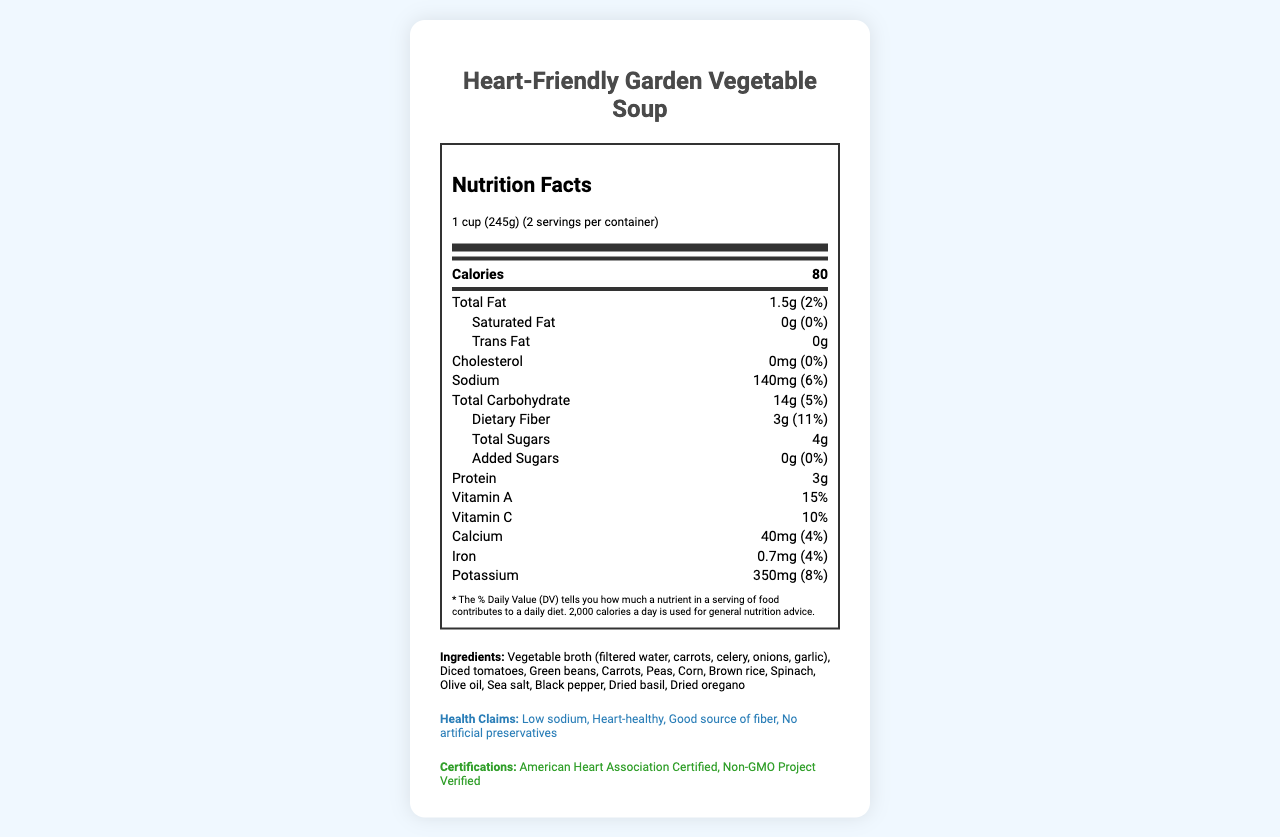what is the serving size? The document specifies the serving size is "1 cup (245g)".
Answer: 1 cup (245g) what is the amount of sodium per serving? The document lists the sodium content as 140mg per serving.
Answer: 140mg how many servings are there per container? The document states there are 2 servings per container.
Answer: 2 what is the percentage of daily value for dietary fiber? The document mentions the daily value for dietary fiber is 11%.
Answer: 11% what vitamins are present in this soup? The document shows that Vitamin A and Vitamin C are present in the soup.
Answer: Vitamin A and Vitamin C is the soup high in saturated fat? The document lists the saturated fat as 0g, with a daily value of 0%.
Answer: No which of the following ingredients is not in the soup? A. Carrots B. Chicken broth C. Olive oil D. Dried oregano Chicken broth is not listed among the ingredients; the soup uses vegetable broth instead.
Answer: B what is the amount of protein per serving? A. 2g B. 3g C. 4g D. 5g The document states the protein content per serving is 3g.
Answer: B does the soup contain added sugars? According to the document, added sugars amount to 0g, with a daily value of 0%.
Answer: No is the soup recognized by any health organizations? The document mentions that the soup is "American Heart Association Certified".
Answer: Yes does the soup contain any allergens? The product is made in a facility that processes soy and wheat, as stated in the allergen information.
Answer: Yes describe the main idea of the document. The main focus of the document is to offer a comprehensive overview of the soup's nutritional benefits and key information to help consumers make informed dietary choices.
Answer: The document provides detailed nutritional information about "Heart-Friendly Garden Vegetable Soup," highlighting its low-sodium content, heart-healthy benefits, and essential nutrients. The document also lists the ingredients, health claims, certifications, allergen information, storage instructions, and preparation tips. what is the shelf life of the soup once opened? The document advises refrigerating the soup after opening and consuming it within 3 days but does not specify the total shelf life.
Answer: Not enough information 